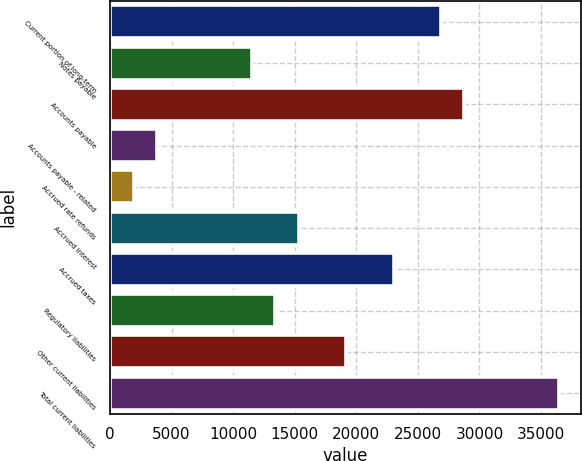Convert chart. <chart><loc_0><loc_0><loc_500><loc_500><bar_chart><fcel>Current portion of long-term<fcel>Notes payable<fcel>Accounts payable<fcel>Accounts payable - related<fcel>Accrued rate refunds<fcel>Accrued interest<fcel>Accrued taxes<fcel>Regulatory liabilities<fcel>Other current liabilities<fcel>Total current liabilities<nl><fcel>26857.8<fcel>11512.2<fcel>28776<fcel>3839.4<fcel>1921.2<fcel>15348.6<fcel>23021.4<fcel>13430.4<fcel>19185<fcel>36448.8<nl></chart> 